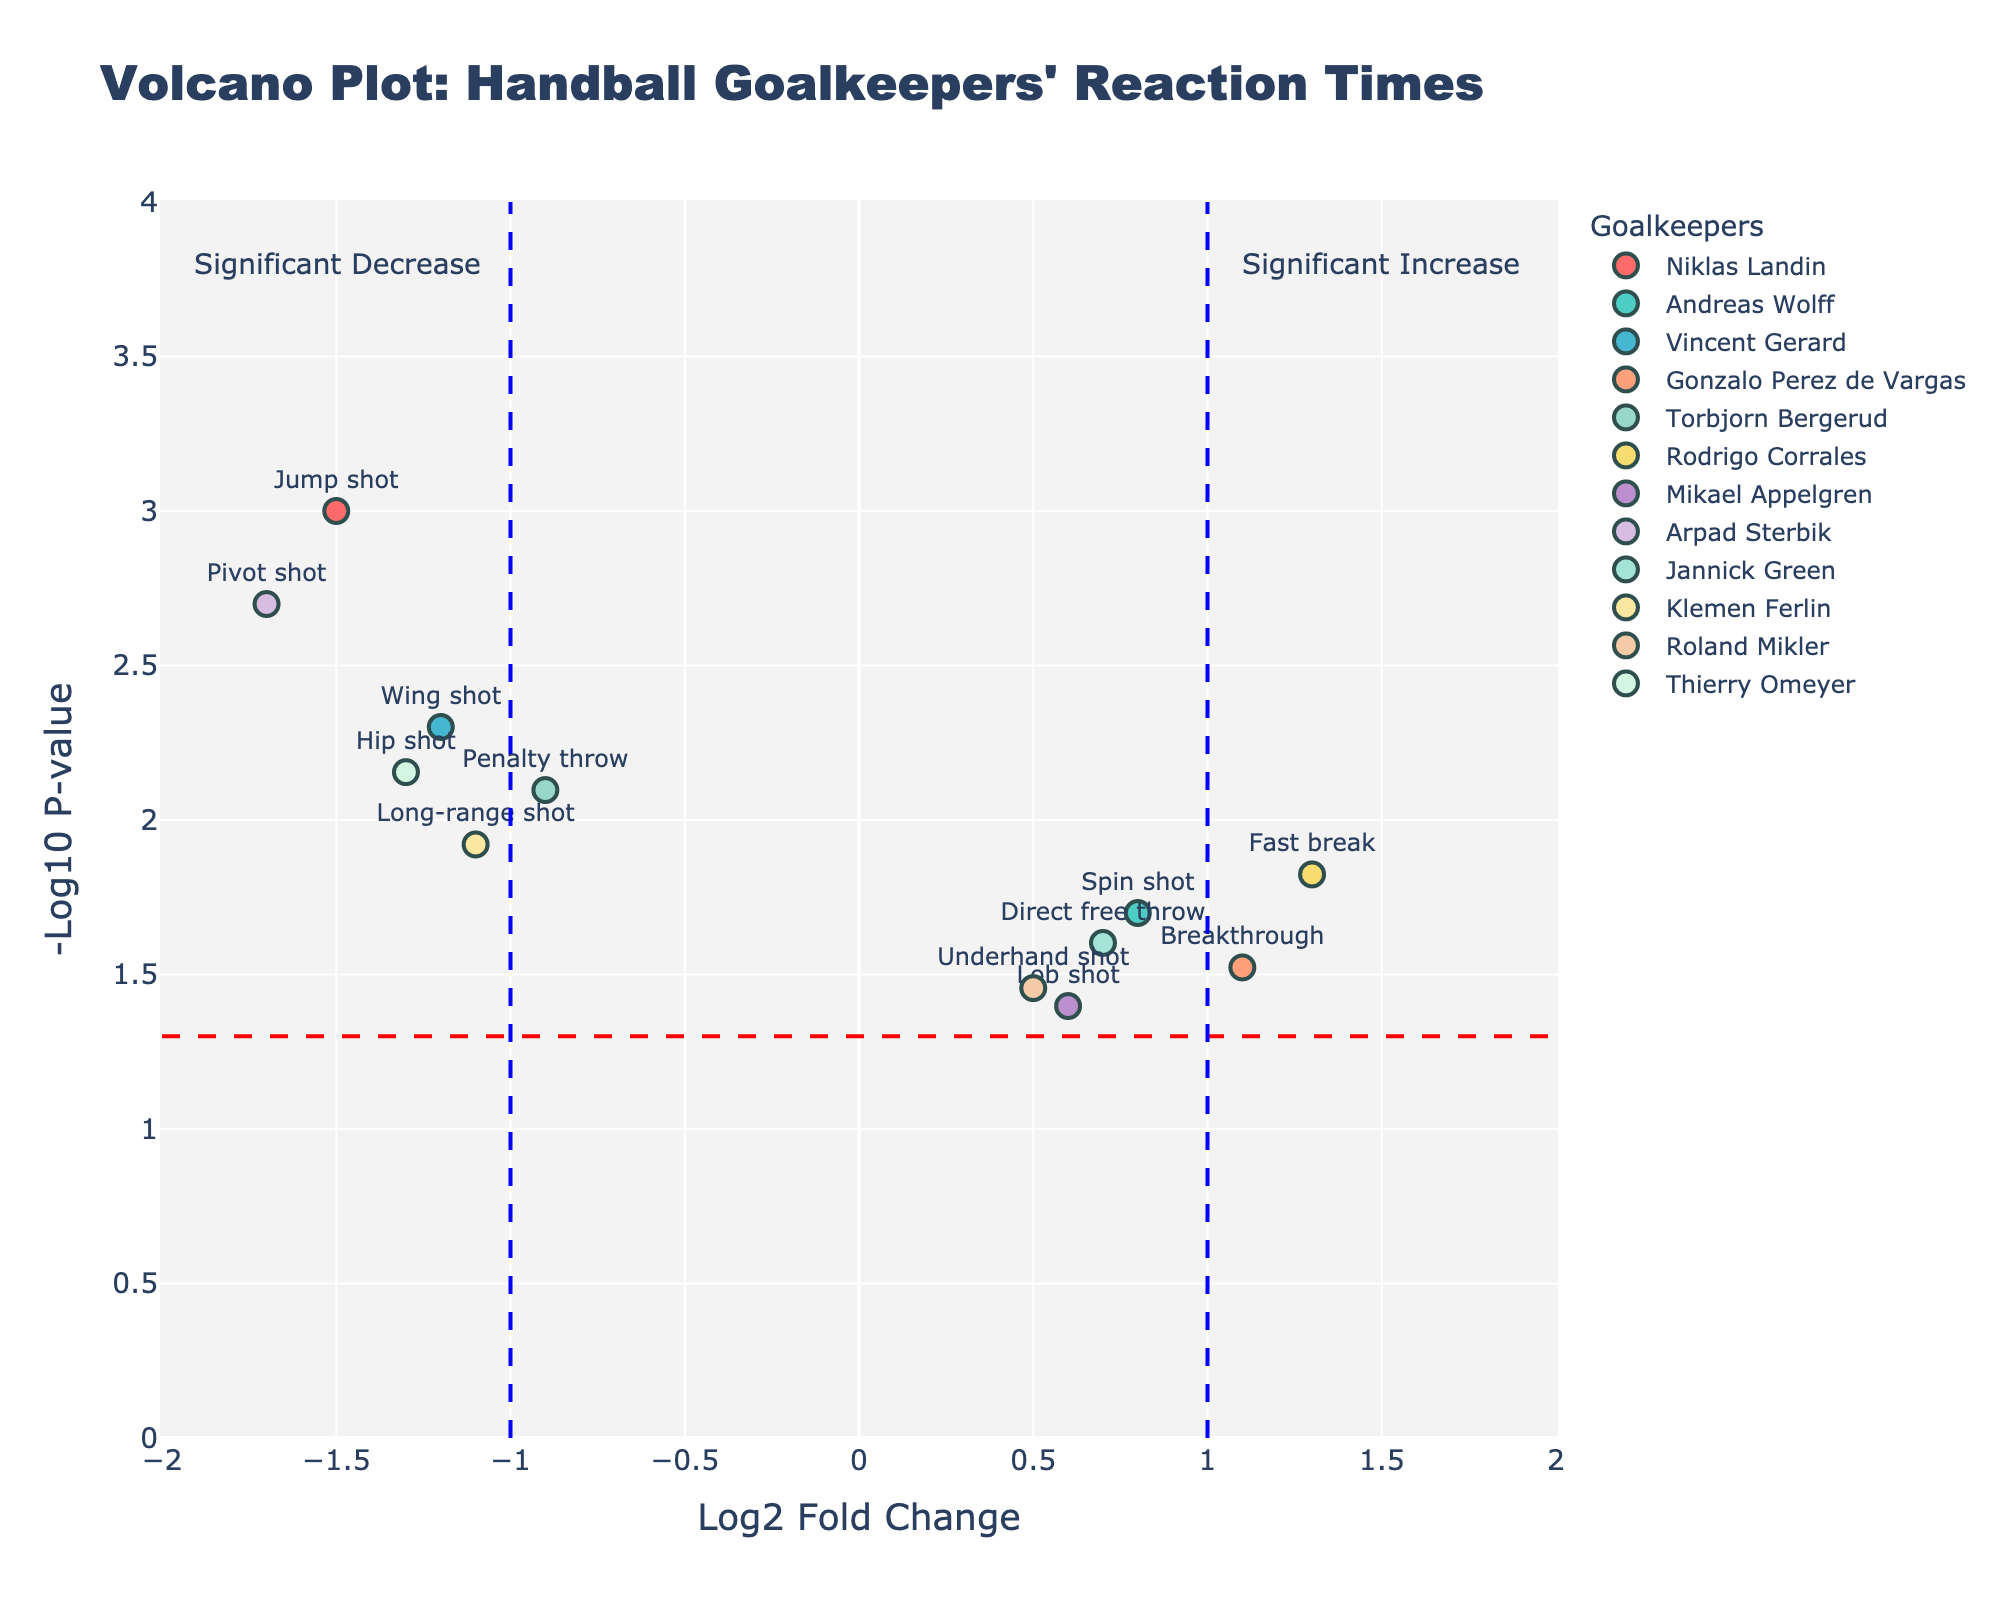How many different shot types are compared in the figure? The figure displays the reaction times for different handball shot types. By counting the individual labels provided for each data point, you can identify the number of unique shot types.
Answer: 12 Which shot type has the lowest p-value? The y-axis represents the -log10 of the p-value, so the highest point on the plot corresponds to the lowest p-value. By looking for the data point with the highest y-value, you identify the shot type with the lowest p-value.
Answer: Jump shot Which goalkeeper has the most significant increase in reaction time? An increase in reaction time corresponds to a positive Log2 Fold Change value. By finding the data point furthest to the right (positive x-axis), you can identify the goalkeeper with the most significant increase.
Answer: Rodrigo Corrales Which data points indicate a significant decrease in reaction times? Significant decreases in reaction times are represented by data points with negative Log2 Fold Change values (left side of the plot) and high -log10 p-values (above the red horizontal line). Look at the points left of zero and above the red line to identify these.
Answer: Jump shot, Wing shot, Penalty throw, Pivot shot, Long-range shot, Hip shot Which shot types have a Log2 Fold Change less than -1 and a p-value less than 0.01? Log2 Fold Change less than -1 places the points on the left side beyond -1 on the x-axis. A p-value less than 0.01 translates to a -log10 p-value greater than 2. By looking for points left of -1 on the x-axis and above the 2 mark on the y-axis, you can find the relevant shot types.
Answer: Jump shot, Wing shot, Pivot shot, Hip shot How are the Log2 Fold Change values distributed for shots resulting in a decrease in reaction time? You can examine the distribution of the Log2 Fold Change values for points that fall on the left side of zero on the x-axis, summarizing the spread and range of these values.
Answer: From -0.9 to -1.7 Which shot type has nearly the same -log10 p-value as the Long-range shot but an opposite reaction time change? Long-range shot has a certain -log10 p-value, and by finding a point with similar y-axis value but an x-axis value on the opposite side, you can identify the corresponding shot type.
Answer: Fast break Are there any shot types for which the change in reaction time is not statistically significant? Statistically insignificant points typically lie below the significance threshold (-log10 p-value of approximately 1.3) denoted by the horizontal line. Check for points under this line.
Answer: Lob shot, Underhand shot What does the vertical blue line at Log2 Fold Change = 1 indicate? This line likely represents the boundary for classifying significant increases in reaction times. Data points further right signify significant increases.
Answer: Significant increase boundary Which goalkeeper reacts the slowest to Breakthrough shots? By locating the data point for Breakthrough on the plot and observing its x-coordinate, you can determine the goalkeeper’s change in reaction time. The positive Log2 Fold Change indicates a slower reaction.
Answer: Gonzalo Perez de Vargas 